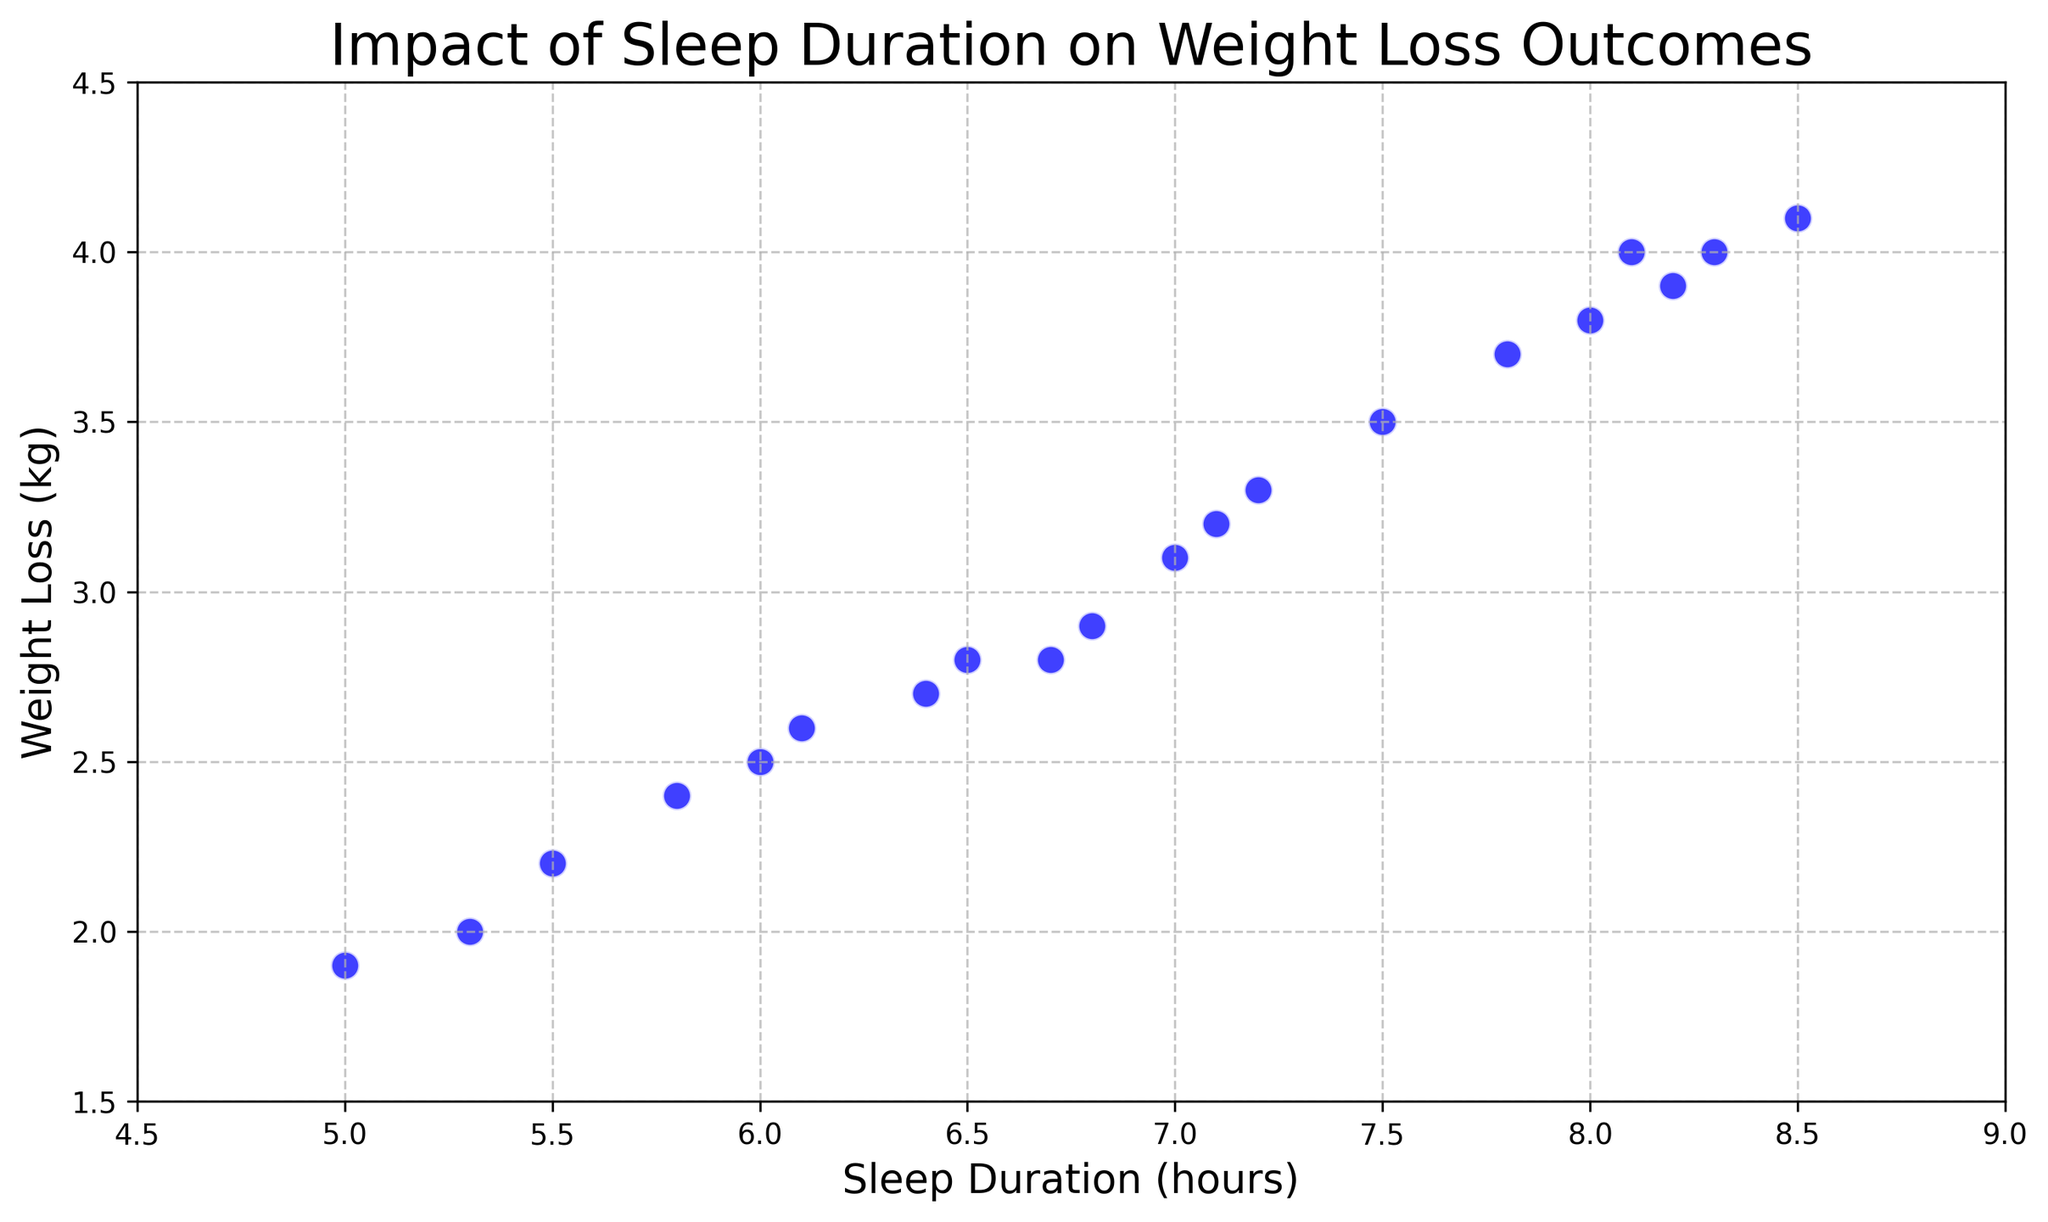What is the range of sleep durations observed in the data? To find the range, identify the minimum and maximum sleep durations in the dataset. The minimum sleep duration is 5, and the maximum is 8.5. Thus, the range is from 5 to 8.5 hours.
Answer: 5 to 8.5 hours Which sleep duration corresponds to the highest weight loss? By examining the scatter plot, identify the point with the highest Y-value for weight loss. The data point with a sleep duration of 8.5 hours has the highest weight loss outcome of 4.1 kg.
Answer: 8.5 hours How many individuals experienced a weight loss of more than 3 kg? Identify the data points where the weight loss is greater than 3 kg. Points with sleep durations 7, 7.2, 7.5, 7.8, 8, 8.1, 8.2, 8.3, and 8.5 correspond to weight losses over 3 kg, so there are 9 such points in total.
Answer: 9 Is there a positive correlation between sleep duration and weight loss? To determine the correlation, observe the trend in the scatter plot. If higher sleep durations tend to be associated with higher weight losses, it indicates a positive correlation. The scatter plot shows that as sleep duration increases, weight loss tends to increase, indicating a positive correlation.
Answer: Yes What is the average weight loss for individuals with sleep durations between 6 and 7 hours? Identify data points with sleep durations between 6 and 7 hours, then calculate their average weight loss. The relevant points are 6, 6.1, 6.4, 6.5, 6.7, and 6.8 with weight losses of 2.5, 2.6, 2.7, 2.8, 2.8, and 2.9 kg respectively. The sum is 16.3 kg and the average is 16.3 / 6 = 2.72 kg.
Answer: 2.72 kg Which sleep duration has the lowest weight loss, and what is that weight loss? Find the data point with the lowest Y-value for weight loss. The sleep duration of 5 hours corresponds to the lowest weight loss of 1.9 kg.
Answer: 5 hours, 1.9 kg 